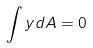Convert formula to latex. <formula><loc_0><loc_0><loc_500><loc_500>\int y d A = 0</formula> 